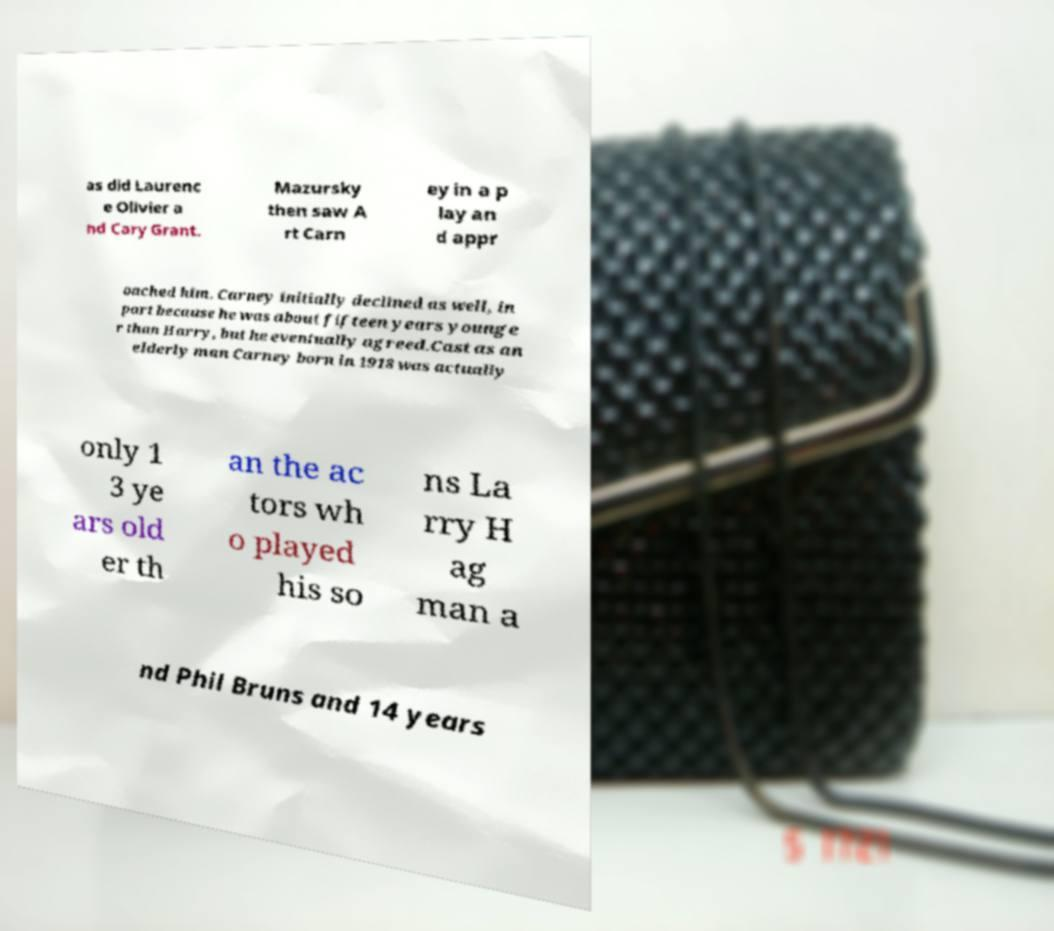Could you extract and type out the text from this image? as did Laurenc e Olivier a nd Cary Grant. Mazursky then saw A rt Carn ey in a p lay an d appr oached him. Carney initially declined as well, in part because he was about fifteen years younge r than Harry, but he eventually agreed.Cast as an elderly man Carney born in 1918 was actually only 1 3 ye ars old er th an the ac tors wh o played his so ns La rry H ag man a nd Phil Bruns and 14 years 